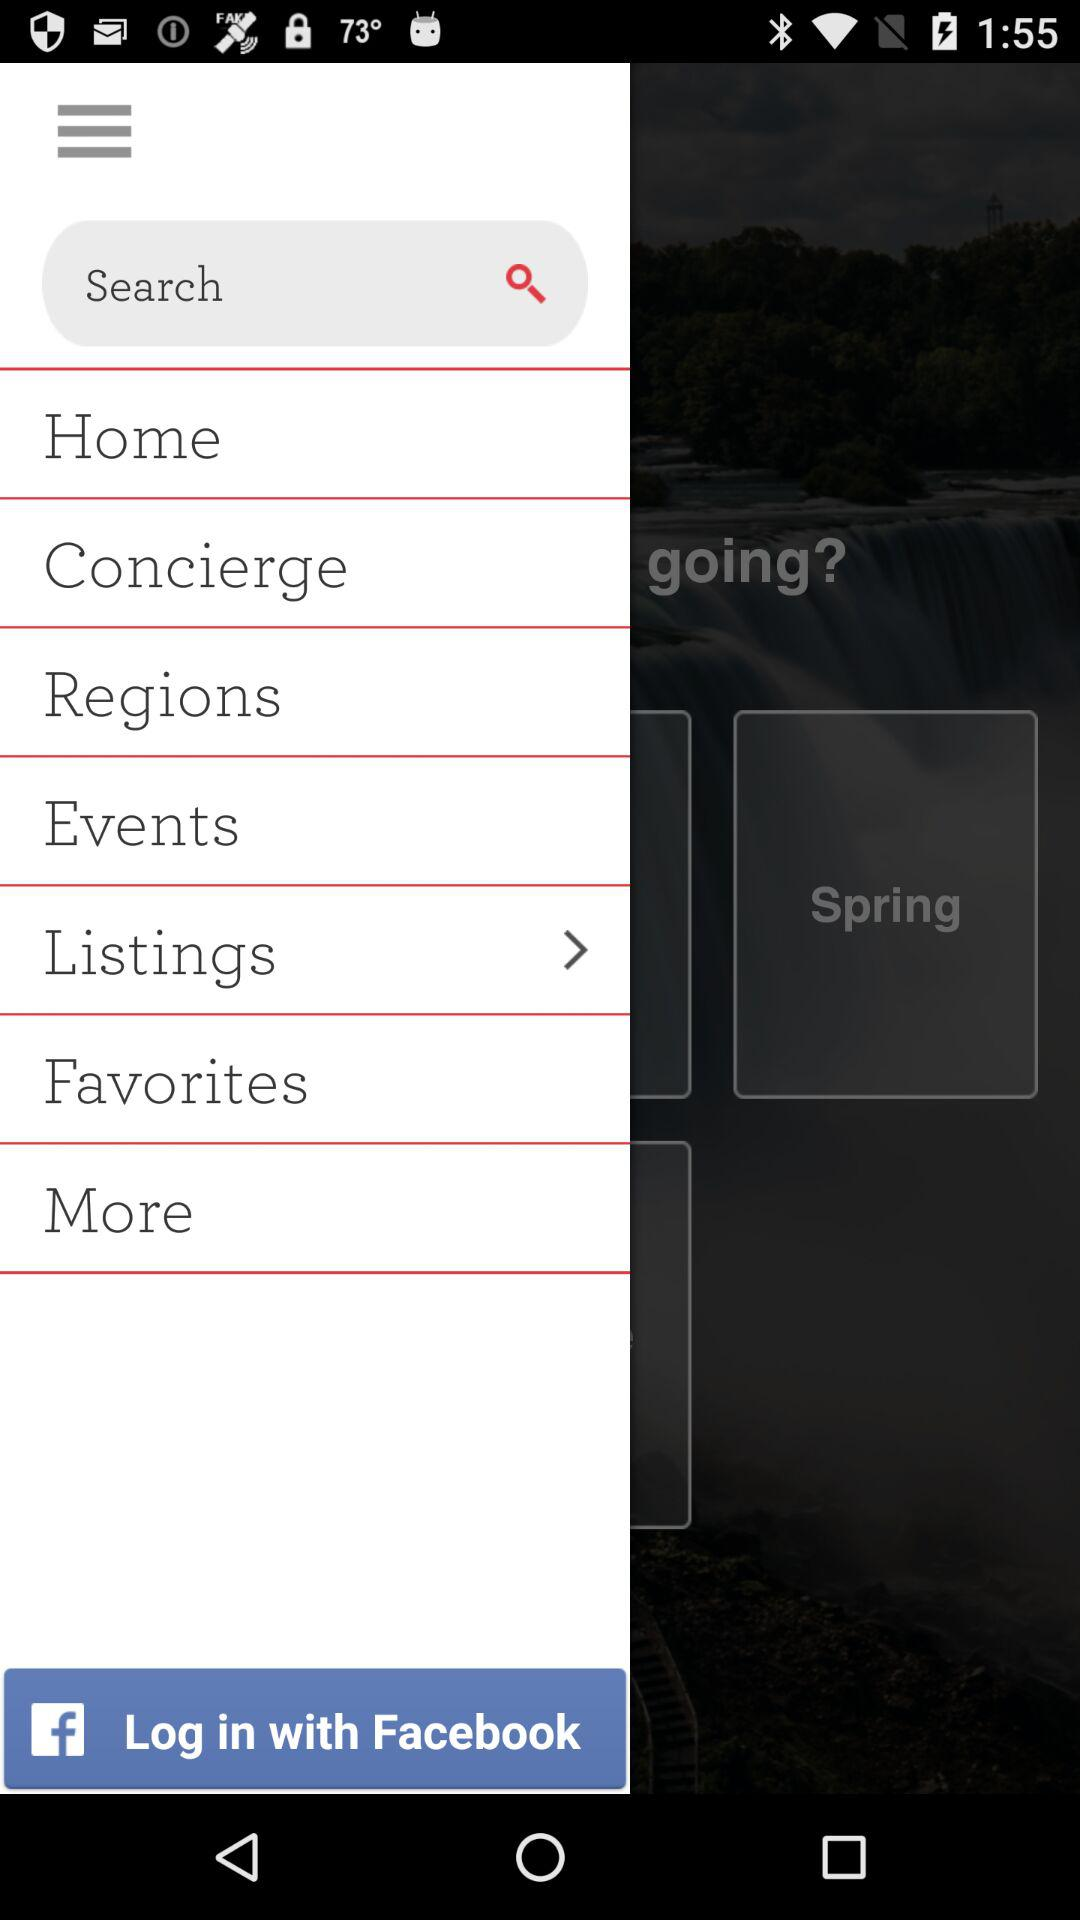Through what application can we log in? We can log in through Facebook. 